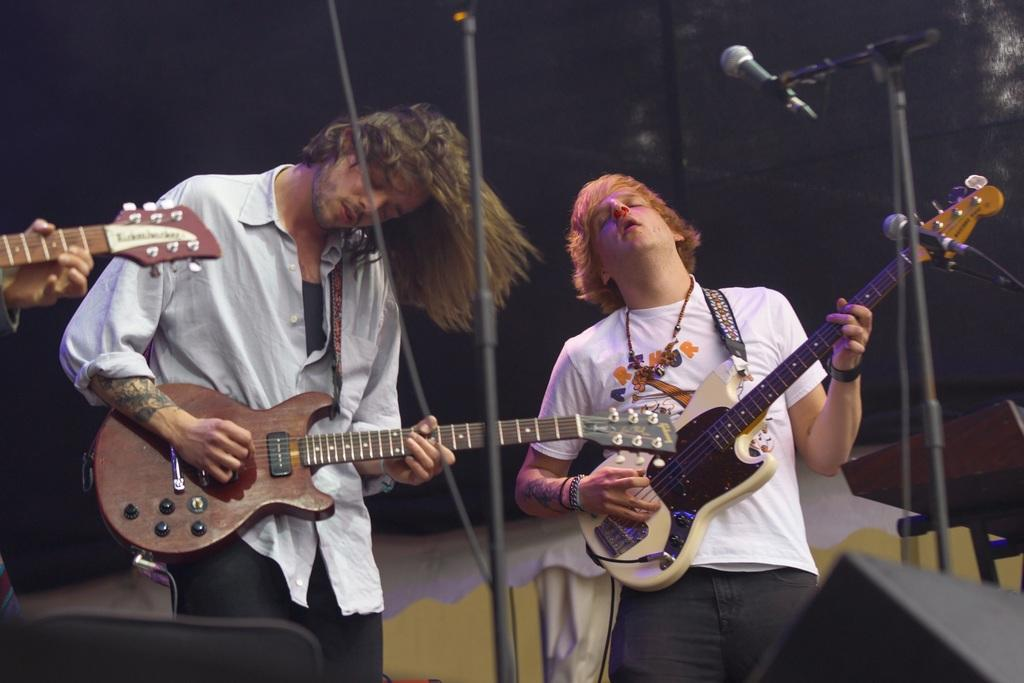How many people are in the image? There are two persons in the image. What are the two persons doing? The two persons are standing and playing guitars. What are the two persons wearing? The two persons are wearing white shirts. What objects are in front of the two persons? There are microphones in front of the two persons. What type of cord is being used by the carpenter in the image? There is no carpenter present in the image, nor is there any cord visible. What kind of soap is being used by the two persons in the image? There is no soap present in the image; the two persons are playing guitars and wearing white shirts. 